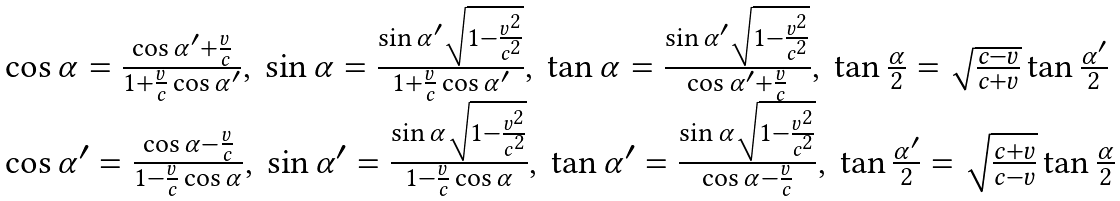<formula> <loc_0><loc_0><loc_500><loc_500>\begin{array} { l } { \cos \alpha = { \frac { \cos \alpha ^ { \prime } + { \frac { v } { c } } } { 1 + { \frac { v } { c } } \cos \alpha ^ { \prime } } } , \ \sin \alpha = { \frac { \sin \alpha ^ { \prime } { \sqrt { 1 - { \frac { v ^ { 2 } } { c ^ { 2 } } } } } } { 1 + { \frac { v } { c } } \cos \alpha ^ { \prime } } } , \ \tan \alpha = { \frac { \sin \alpha ^ { \prime } { \sqrt { 1 - { \frac { v ^ { 2 } } { c ^ { 2 } } } } } } { \cos \alpha ^ { \prime } + { \frac { v } { c } } } } , \ \tan { \frac { \alpha } { 2 } } = { \sqrt { \frac { c - v } { c + v } } } \tan { \frac { \alpha ^ { \prime } } { 2 } } } \\ { \cos \alpha ^ { \prime } = { \frac { \cos \alpha - { \frac { v } { c } } } { 1 - { \frac { v } { c } } \cos \alpha } } , \ \sin \alpha ^ { \prime } = { \frac { \sin \alpha { \sqrt { 1 - { \frac { v ^ { 2 } } { c ^ { 2 } } } } } } { 1 - { \frac { v } { c } } \cos \alpha } } , \ \tan \alpha ^ { \prime } = { \frac { \sin \alpha { \sqrt { 1 - { \frac { v ^ { 2 } } { c ^ { 2 } } } } } } { \cos \alpha - { \frac { v } { c } } } } , \ \tan { \frac { \alpha ^ { \prime } } { 2 } } = { \sqrt { \frac { c + v } { c - v } } } \tan { \frac { \alpha } { 2 } } } \end{array}</formula> 